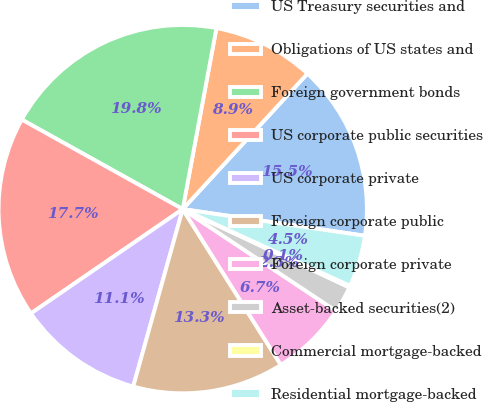Convert chart. <chart><loc_0><loc_0><loc_500><loc_500><pie_chart><fcel>US Treasury securities and<fcel>Obligations of US states and<fcel>Foreign government bonds<fcel>US corporate public securities<fcel>US corporate private<fcel>Foreign corporate public<fcel>Foreign corporate private<fcel>Asset-backed securities(2)<fcel>Commercial mortgage-backed<fcel>Residential mortgage-backed<nl><fcel>15.47%<fcel>8.91%<fcel>19.85%<fcel>17.66%<fcel>11.09%<fcel>13.28%<fcel>6.72%<fcel>2.34%<fcel>0.15%<fcel>4.53%<nl></chart> 